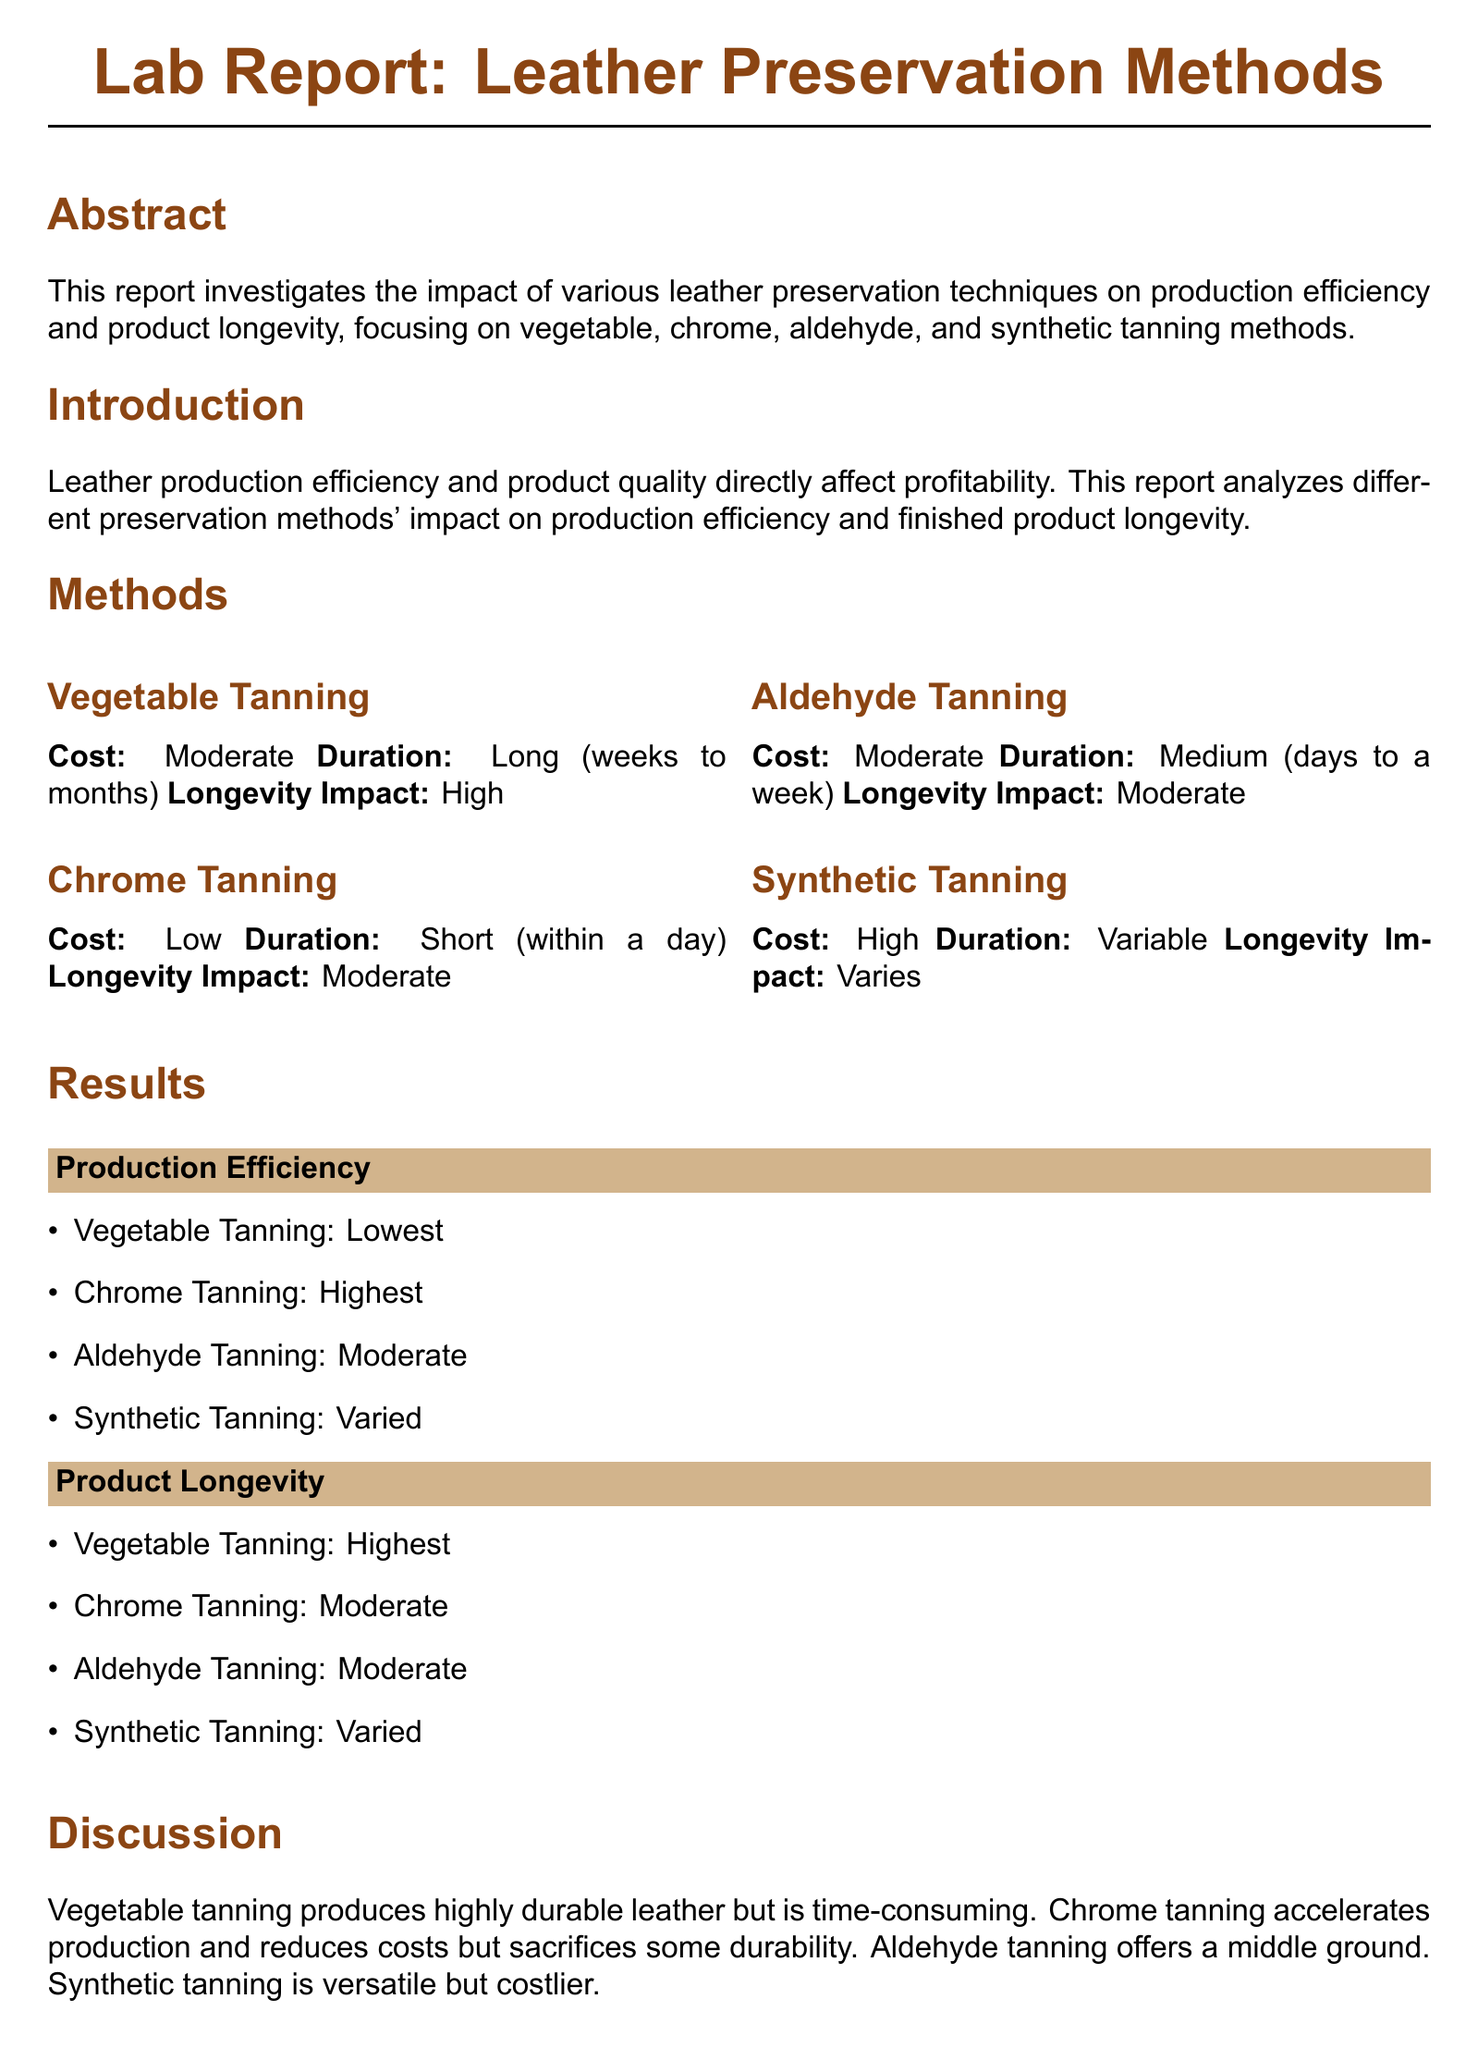What is the focus of the lab report? The focus of the lab report is to investigate the impact of various leather preservation techniques on production efficiency and product longevity.
Answer: impact of various leather preservation techniques What is the cost of chrome tanning? The document states chrome tanning has a low cost.
Answer: Low Which tanning method has the highest longevity impact? According to the report, vegetable tanning has the highest longevity impact.
Answer: High What is the production efficiency ranking for vegetable tanning? The report indicates that vegetable tanning has the lowest production efficiency.
Answer: Lowest What does synthetic tanning's cost classification indicate? The report classifies synthetic tanning as high cost, which means it is expensive compared to other methods.
Answer: High What is the duration for chrome tanning? The duration for chrome tanning, as mentioned in the report, is short.
Answer: Short Which tanning method offers a middle ground in terms of longevity impact? Aldehyde tanning is mentioned as providing a middle ground between preservation methods regarding longevity impact.
Answer: Aldehyde Tanning What is suggested for premium product lines in the conclusion? The conclusion suggests considering vegetable tanning for premium product lines where longevity is critical.
Answer: Vegetable Tanning How is the overall recommendation categorized in the report? The recommendation in the report categorizes chrome tanning as beneficial for high-volume production while weighing its cost-effectiveness.
Answer: chrome tanning 